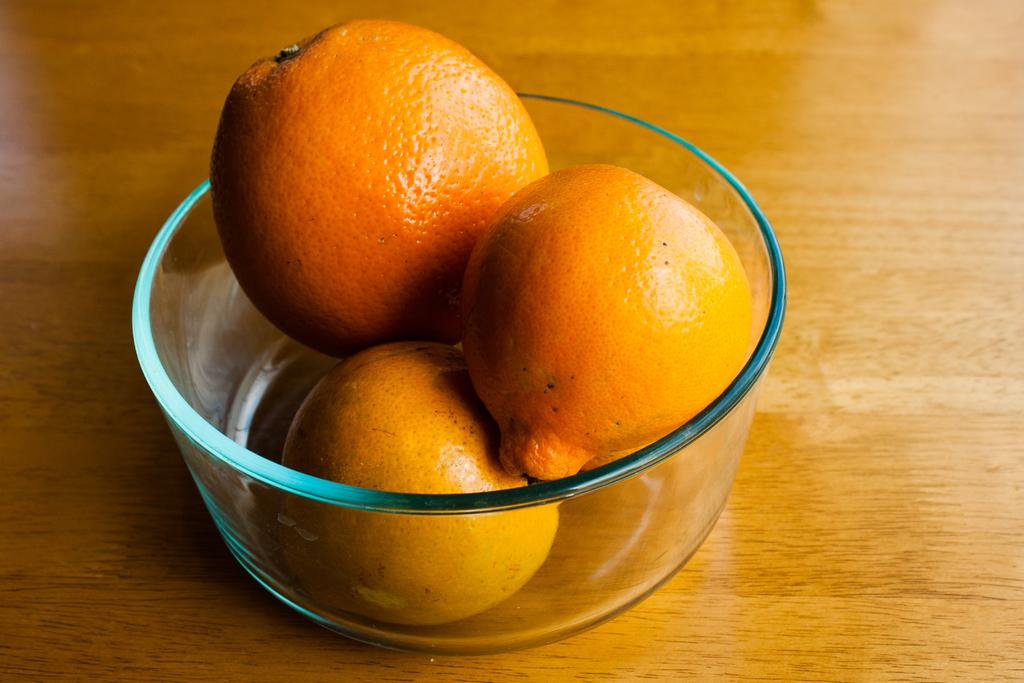What type of fruit is present in the image? There are oranges in the image. How are the oranges arranged in the image? The oranges are in a bowl. What is the surface material beneath the bowl in the image? The bowl is on a wooden surface. How many bells can be seen hanging from the oranges in the image? There are no bells present in the image; it only features oranges in a bowl on a wooden surface. 